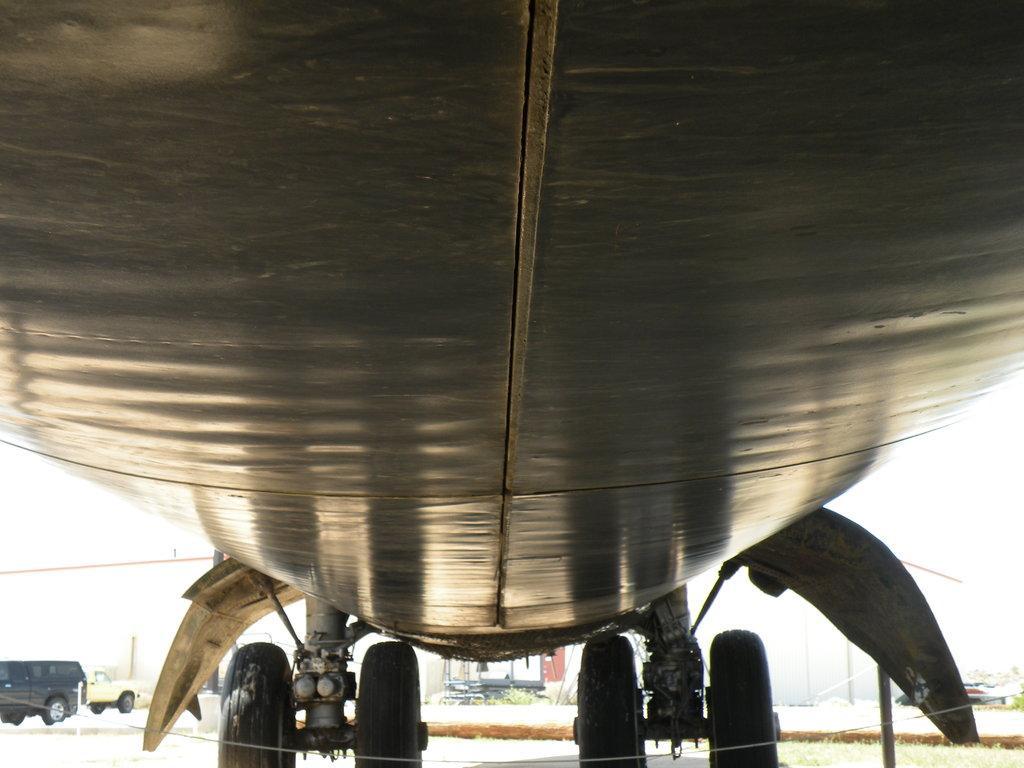Please provide a concise description of this image. There is an aircraft having four wheels on the ground. In the background, there are two vehicles. And the background is white in color. 